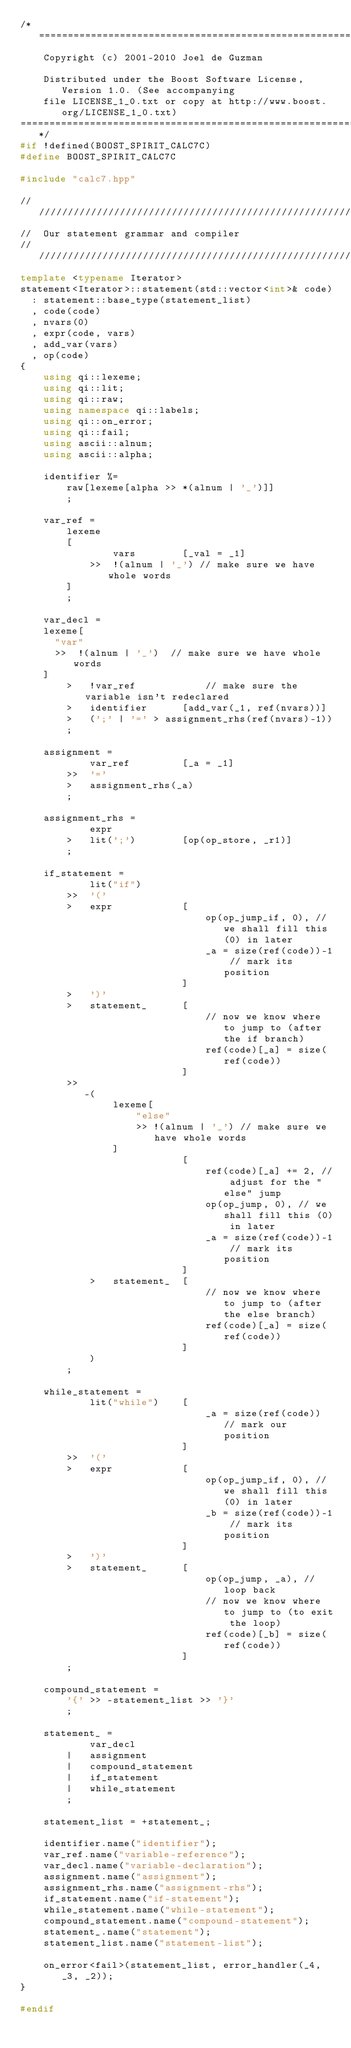<code> <loc_0><loc_0><loc_500><loc_500><_C++_>/*=============================================================================
    Copyright (c) 2001-2010 Joel de Guzman

    Distributed under the Boost Software License, Version 1.0. (See accompanying
    file LICENSE_1_0.txt or copy at http://www.boost.org/LICENSE_1_0.txt)
=============================================================================*/
#if !defined(BOOST_SPIRIT_CALC7C)
#define BOOST_SPIRIT_CALC7C

#include "calc7.hpp"

///////////////////////////////////////////////////////////////////////////////
//  Our statement grammar and compiler
///////////////////////////////////////////////////////////////////////////////
template <typename Iterator>
statement<Iterator>::statement(std::vector<int>& code)
  : statement::base_type(statement_list)
  , code(code)
  , nvars(0)
  , expr(code, vars)
  , add_var(vars)
  , op(code)
{
    using qi::lexeme;
    using qi::lit;
    using qi::raw;
    using namespace qi::labels;
    using qi::on_error;
    using qi::fail;
    using ascii::alnum;
    using ascii::alpha;

    identifier %=
        raw[lexeme[alpha >> *(alnum | '_')]]
        ;

    var_ref =
        lexeme
        [
                vars        [_val = _1]
            >>  !(alnum | '_') // make sure we have whole words
        ]
        ;

    var_decl =
		lexeme[
			"var"
			>>  !(alnum | '_')	// make sure we have whole words
		]        
        >   !var_ref            // make sure the variable isn't redeclared
        >   identifier      [add_var(_1, ref(nvars))]
        >   (';' | '=' > assignment_rhs(ref(nvars)-1))
        ;

    assignment =
            var_ref         [_a = _1]
        >>  '='
        >   assignment_rhs(_a)
        ;

    assignment_rhs =
            expr
        >   lit(';')        [op(op_store, _r1)]
        ;

    if_statement =
            lit("if")
        >>  '('
        >   expr            [
                                op(op_jump_if, 0), // we shall fill this (0) in later
                                _a = size(ref(code))-1 // mark its position
                            ]
        >   ')'
        >   statement_      [
                                // now we know where to jump to (after the if branch)
                                ref(code)[_a] = size(ref(code))
                            ]
        >>
           -(
                lexeme[
                    "else"
                    >> !(alnum | '_') // make sure we have whole words
                ]
                            [
                                ref(code)[_a] += 2, // adjust for the "else" jump
                                op(op_jump, 0), // we shall fill this (0) in later
                                _a = size(ref(code))-1 // mark its position
                            ]
            >   statement_  [
                                // now we know where to jump to (after the else branch)
                                ref(code)[_a] = size(ref(code))
                            ]
            )
        ;

    while_statement =
            lit("while")    [
                                _a = size(ref(code)) // mark our position
                            ]
        >>  '('
        >   expr            [
                                op(op_jump_if, 0), // we shall fill this (0) in later
                                _b = size(ref(code))-1 // mark its position
                            ]
        >   ')'
        >   statement_      [
                                op(op_jump, _a), // loop back
                                // now we know where to jump to (to exit the loop)
                                ref(code)[_b] = size(ref(code))
                            ]
        ;

    compound_statement =
        '{' >> -statement_list >> '}'
        ;

    statement_ =
            var_decl
        |   assignment
        |   compound_statement
        |   if_statement
        |   while_statement
        ;

    statement_list = +statement_;

    identifier.name("identifier");
    var_ref.name("variable-reference");
    var_decl.name("variable-declaration");
    assignment.name("assignment");
    assignment_rhs.name("assignment-rhs");
    if_statement.name("if-statement");
    while_statement.name("while-statement");
    compound_statement.name("compound-statement");
    statement_.name("statement");
    statement_list.name("statement-list");

    on_error<fail>(statement_list, error_handler(_4, _3, _2));
}

#endif


</code> 